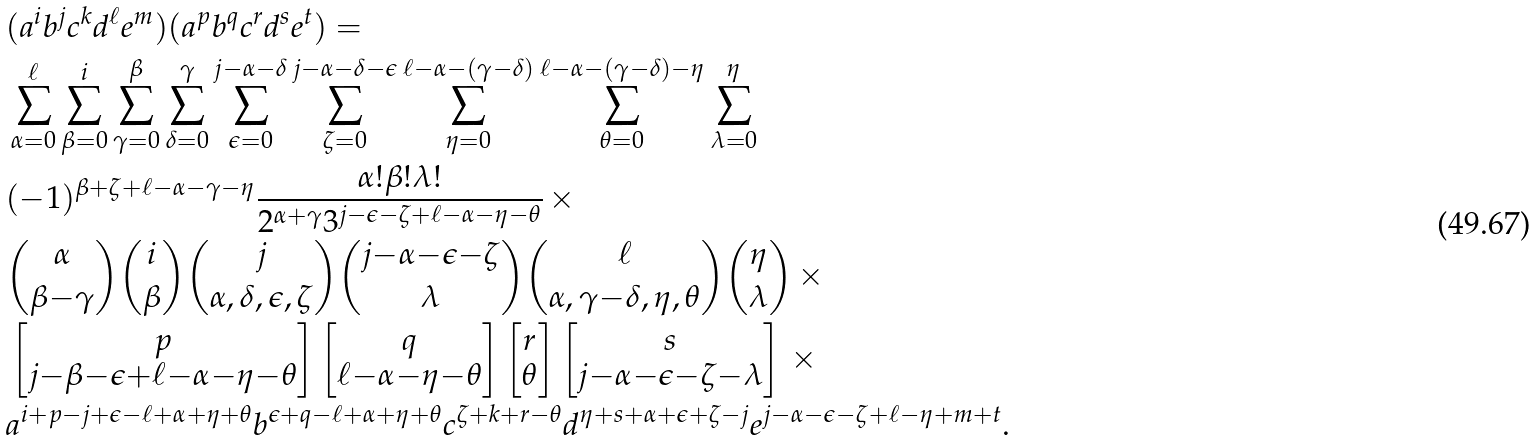<formula> <loc_0><loc_0><loc_500><loc_500>& ( a ^ { i } b ^ { j } c ^ { k } d ^ { \ell } e ^ { m } ) ( a ^ { p } b ^ { q } c ^ { r } d ^ { s } e ^ { t } ) = \\ & \sum _ { \alpha = 0 } ^ { \ell } \sum _ { \beta = 0 } ^ { i } \sum _ { \gamma = 0 } ^ { \beta } \sum _ { \delta = 0 } ^ { \gamma } \sum _ { \epsilon = 0 } ^ { j - \alpha - \delta } \sum _ { \zeta = 0 } ^ { j - \alpha - \delta - \epsilon } \sum _ { \eta = 0 } ^ { \ell - \alpha - ( \gamma - \delta ) } \sum _ { \theta = 0 } ^ { \ell - \alpha - ( \gamma - \delta ) - \eta } \sum _ { \lambda = 0 } ^ { \eta } \\ & ( - 1 ) ^ { \beta + \zeta + \ell - \alpha - \gamma - \eta } \frac { \alpha ! \beta ! \lambda ! } { 2 ^ { \alpha + \gamma } 3 ^ { j - \epsilon - \zeta + \ell - \alpha - \eta - \theta } } \, \times \\ & \binom { \alpha } { \beta { - } \gamma } \binom { i } { \beta } \binom { j } { \alpha , \delta , \epsilon , \zeta } \binom { j { - } \alpha { - } \epsilon { - } \zeta } { \lambda } \binom { \ell } { \alpha , \gamma { - } \delta , \eta , \theta } \binom { \eta } { \lambda } \, \times \\ & \begin{bmatrix} p \\ j { - } \beta { - } \epsilon { + } \ell { - } \alpha { - } \eta { - } \theta \end{bmatrix} \begin{bmatrix} q \\ \ell { - } \alpha { - } \eta { - } \theta \end{bmatrix} \begin{bmatrix} r \\ \theta \end{bmatrix} \begin{bmatrix} s \\ j { - } \alpha { - } \epsilon { - } \zeta { - } \lambda \end{bmatrix} \, \times \\ & a ^ { i { + } p { - } j { + } \epsilon { - } \ell { + } \alpha { + } \eta { + } \theta } b ^ { \epsilon { + } q { - } \ell { + } \alpha { + } \eta { + } \theta } c ^ { \zeta { + } k { + } r { - } \theta } d ^ { \eta { + } s { + } \alpha { + } \epsilon { + } \zeta { - } j } e ^ { j { - } \alpha { - } \epsilon { - } \zeta { + } \ell { - } \eta { + } m { + } t } .</formula> 